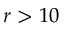Convert formula to latex. <formula><loc_0><loc_0><loc_500><loc_500>r > 1 0</formula> 